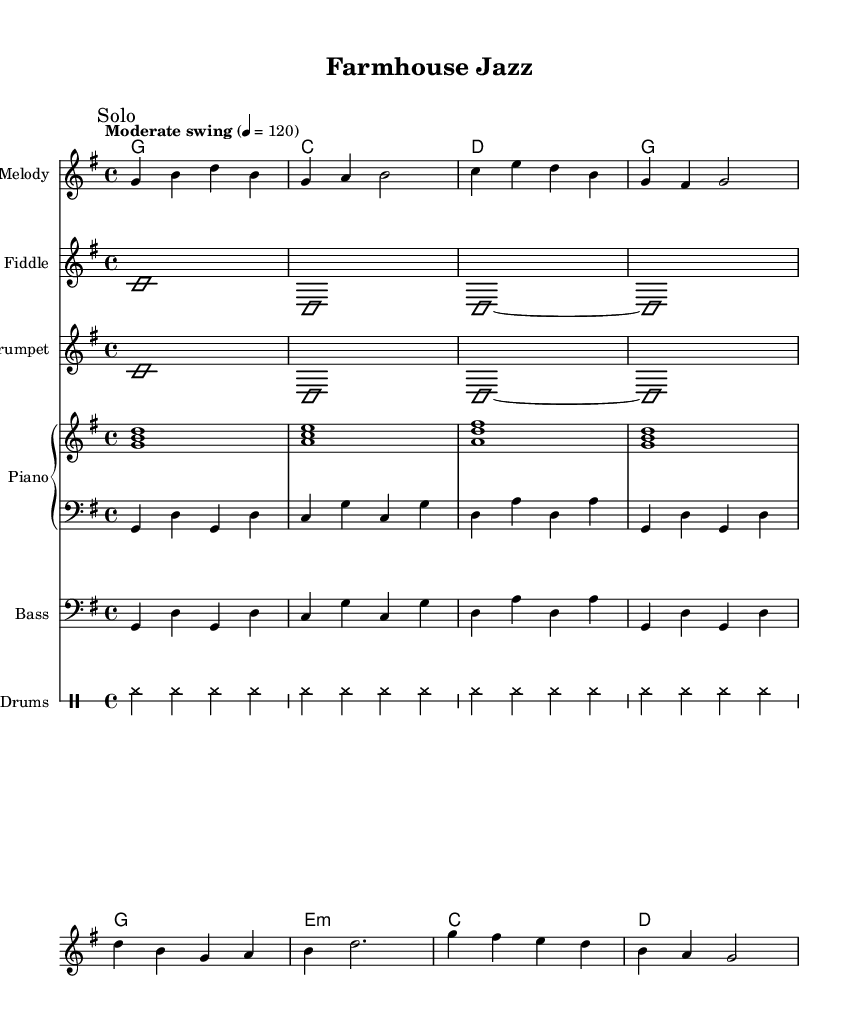What is the key signature of this music? The key signature is G major, which has one sharp (F#). This can be determined by looking at the key signature at the beginning of the staff.
Answer: G major What is the time signature of this music? The time signature is four-four, which is indicated at the beginning of the score. It defines how many beats are in each measure and what note value gets one beat.
Answer: 4/4 What tempo marking is indicated? The tempo marking is "Moderate swing," which suggests a relaxed, swinging feel. This is found at the top of the score (above the staff).
Answer: Moderate swing What instruments are featured in this piece? The instruments featured are melody, fiddle, trumpet, piano, bass, and drums, as indicated by the labeled staves in the score.
Answer: Fiddle, trumpet, piano, bass, drums How many measures are there in the melody section? The melody section consists of 8 measures; this can be counted from the beginning of the melody phrase to the end of the first chorus. Each horizontal line across the staff symbolizes a measure.
Answer: 8 measures Which instrument features improvisation in this piece? Both the fiddle and trumpet sections are marked with "Solo" and have "improvisationOn" indicating that they allow for improvisation. In the score, these sections are labeled clearly.
Answer: Fiddle, trumpet What chord appears at the end of the harmony section? The last chord in the harmony section is G major, indicated by "g" in the chord mode. It follows the established chord progression throughout the score.
Answer: G 